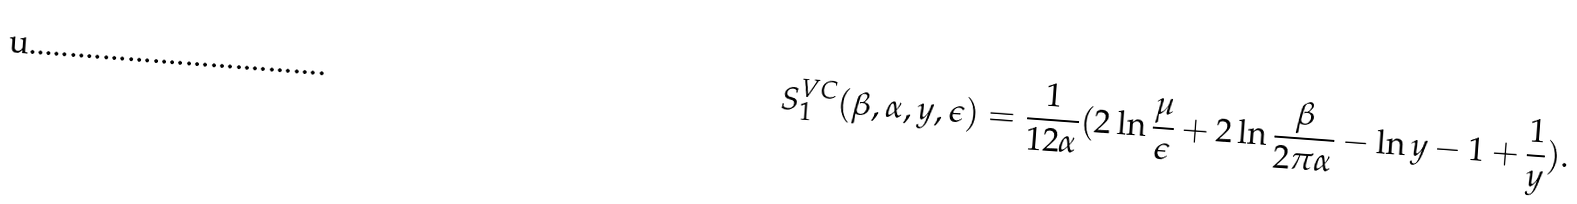Convert formula to latex. <formula><loc_0><loc_0><loc_500><loc_500>S _ { 1 } ^ { V C } ( \beta , \alpha , y , \epsilon ) = \frac { 1 } { 1 2 \alpha } ( 2 \ln \frac { \mu } { \epsilon } + 2 \ln \frac { \beta } { 2 \pi \alpha } - \ln y - 1 + \frac { 1 } { y } ) .</formula> 